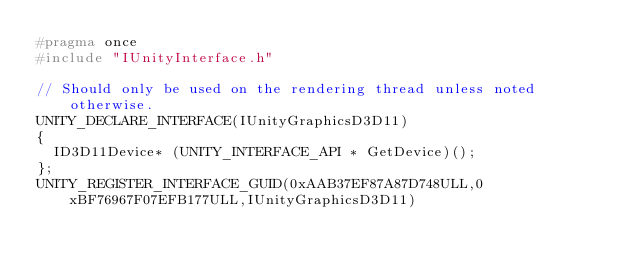<code> <loc_0><loc_0><loc_500><loc_500><_C_>#pragma once
#include "IUnityInterface.h"

// Should only be used on the rendering thread unless noted otherwise.
UNITY_DECLARE_INTERFACE(IUnityGraphicsD3D11)
{
	ID3D11Device* (UNITY_INTERFACE_API * GetDevice)();
};
UNITY_REGISTER_INTERFACE_GUID(0xAAB37EF87A87D748ULL,0xBF76967F07EFB177ULL,IUnityGraphicsD3D11)
</code> 